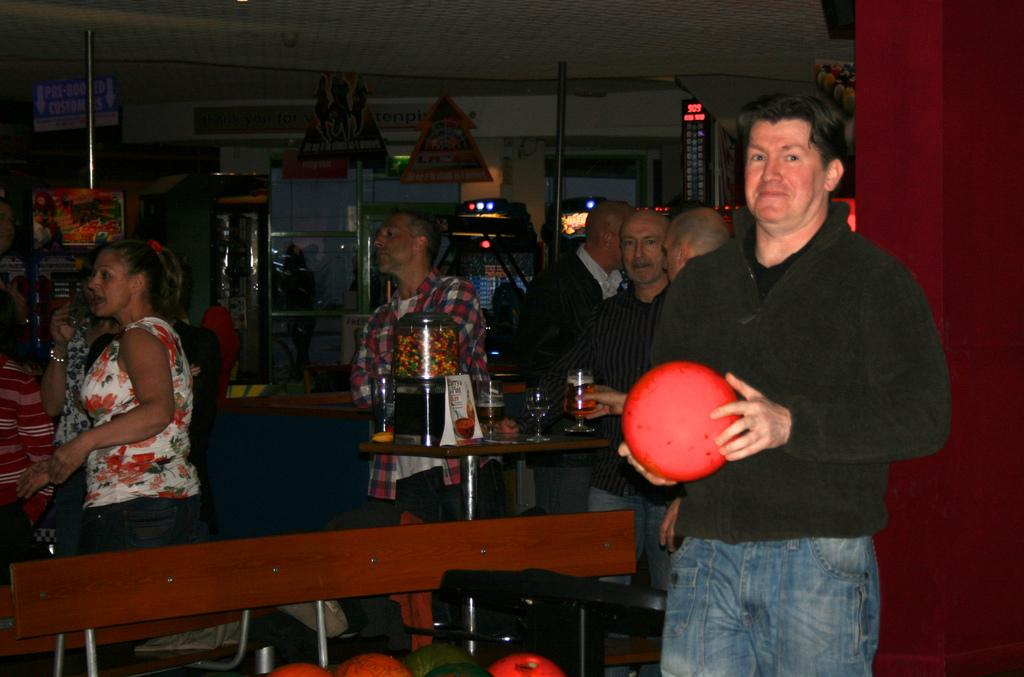Who is the main subject in the image? There is a man in the image. What is the man holding in his hands? The man is holding a red color ball in his hands. What is the man's posture in the image? The man is standing. What can be seen in the background of the image? There are people and glasses on a table in the background of the image. What type of writer is the man in the image? There is no indication in the image that the man is a writer, as he is holding a red color ball and not engaged in any writing activity. 